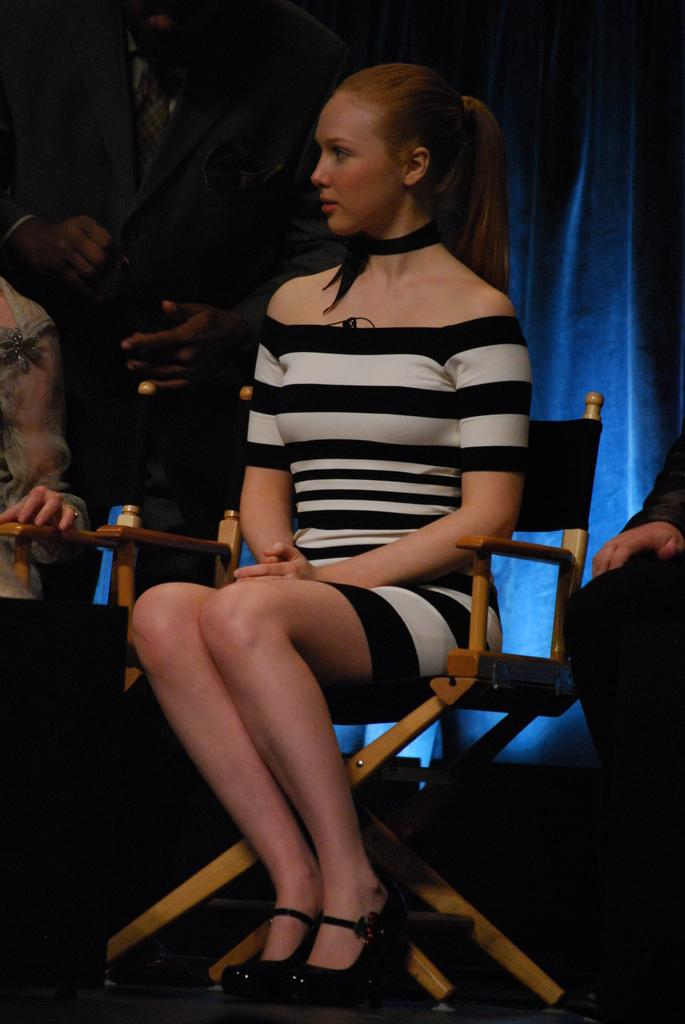Who is the main subject in the image? There is a lady in the image. What is the lady doing in the image? The lady is sitting on a chair. Are there any other people visible in the image? Yes, there are people behind the lady. What can be seen at the back of the scene? There is a curtain at the back of the scene. What type of steel is used to construct the chair the lady is sitting on? The facts provided do not mention the type of steel used in the chair, nor do they mention any steel at all. The chair's construction material is not specified. 